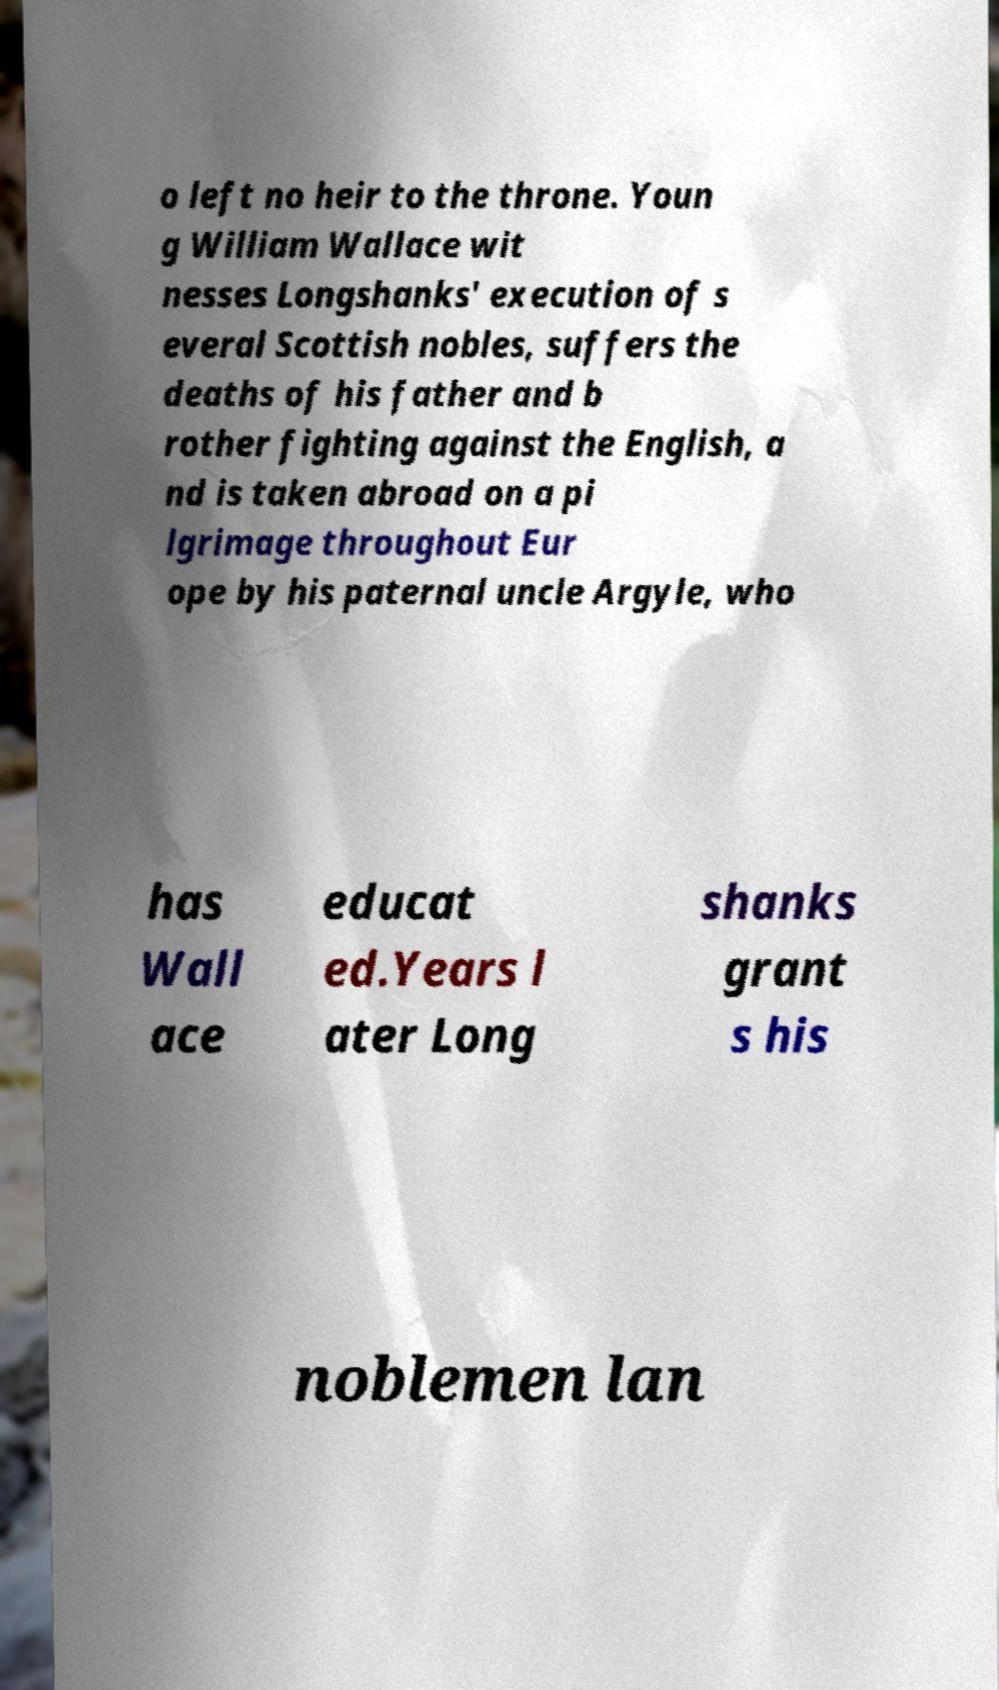Please identify and transcribe the text found in this image. o left no heir to the throne. Youn g William Wallace wit nesses Longshanks' execution of s everal Scottish nobles, suffers the deaths of his father and b rother fighting against the English, a nd is taken abroad on a pi lgrimage throughout Eur ope by his paternal uncle Argyle, who has Wall ace educat ed.Years l ater Long shanks grant s his noblemen lan 